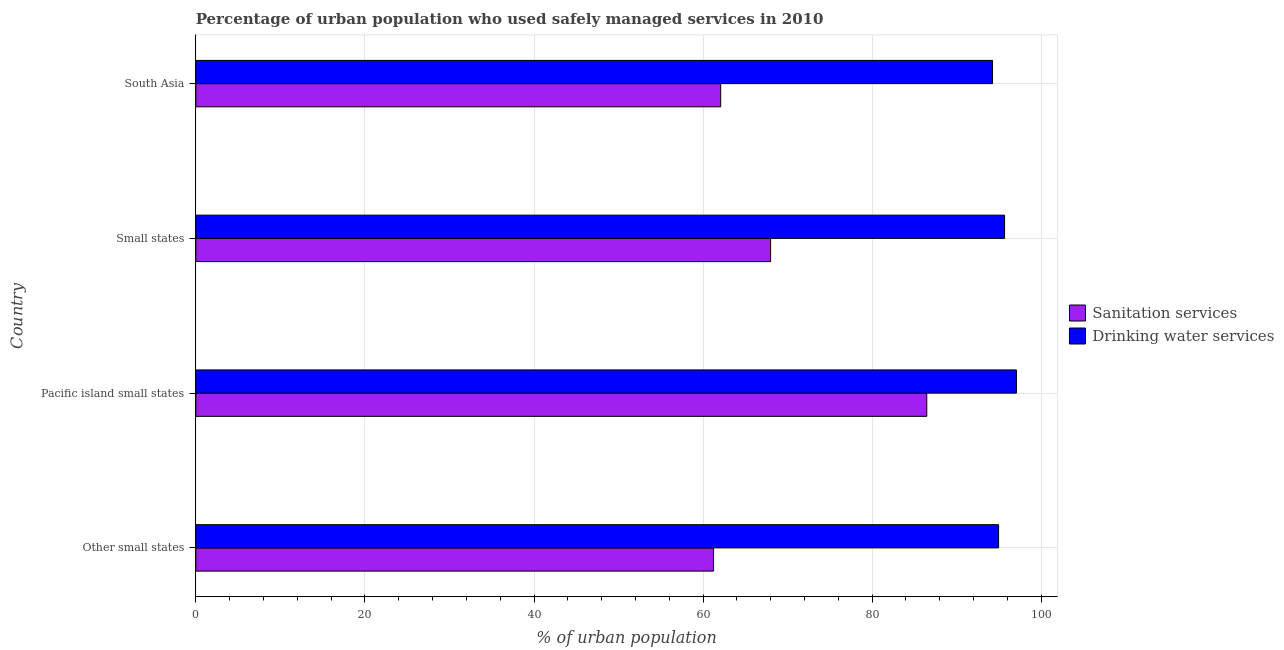Are the number of bars on each tick of the Y-axis equal?
Ensure brevity in your answer.  Yes. How many bars are there on the 2nd tick from the top?
Offer a terse response. 2. How many bars are there on the 2nd tick from the bottom?
Ensure brevity in your answer.  2. What is the label of the 3rd group of bars from the top?
Give a very brief answer. Pacific island small states. What is the percentage of urban population who used drinking water services in Small states?
Keep it short and to the point. 95.66. Across all countries, what is the maximum percentage of urban population who used drinking water services?
Your response must be concise. 97.07. Across all countries, what is the minimum percentage of urban population who used sanitation services?
Offer a very short reply. 61.24. In which country was the percentage of urban population who used drinking water services maximum?
Your answer should be very brief. Pacific island small states. In which country was the percentage of urban population who used drinking water services minimum?
Keep it short and to the point. South Asia. What is the total percentage of urban population who used sanitation services in the graph?
Provide a succinct answer. 277.77. What is the difference between the percentage of urban population who used sanitation services in Other small states and that in Pacific island small states?
Give a very brief answer. -25.22. What is the difference between the percentage of urban population who used sanitation services in Pacific island small states and the percentage of urban population who used drinking water services in Small states?
Make the answer very short. -9.2. What is the average percentage of urban population who used drinking water services per country?
Offer a very short reply. 95.48. What is the difference between the percentage of urban population who used drinking water services and percentage of urban population who used sanitation services in Other small states?
Offer a terse response. 33.72. In how many countries, is the percentage of urban population who used drinking water services greater than 60 %?
Offer a terse response. 4. Is the percentage of urban population who used sanitation services in Other small states less than that in Pacific island small states?
Make the answer very short. Yes. What is the difference between the highest and the second highest percentage of urban population who used sanitation services?
Your answer should be compact. 18.47. What is the difference between the highest and the lowest percentage of urban population who used drinking water services?
Your answer should be compact. 2.83. Is the sum of the percentage of urban population who used drinking water services in Pacific island small states and Small states greater than the maximum percentage of urban population who used sanitation services across all countries?
Your answer should be compact. Yes. What does the 2nd bar from the top in Pacific island small states represents?
Ensure brevity in your answer.  Sanitation services. What does the 2nd bar from the bottom in South Asia represents?
Make the answer very short. Drinking water services. How many bars are there?
Your answer should be compact. 8. How many countries are there in the graph?
Provide a succinct answer. 4. Does the graph contain any zero values?
Ensure brevity in your answer.  No. Does the graph contain grids?
Keep it short and to the point. Yes. How many legend labels are there?
Provide a short and direct response. 2. How are the legend labels stacked?
Your answer should be compact. Vertical. What is the title of the graph?
Keep it short and to the point. Percentage of urban population who used safely managed services in 2010. What is the label or title of the X-axis?
Give a very brief answer. % of urban population. What is the label or title of the Y-axis?
Your answer should be very brief. Country. What is the % of urban population in Sanitation services in Other small states?
Keep it short and to the point. 61.24. What is the % of urban population in Drinking water services in Other small states?
Keep it short and to the point. 94.96. What is the % of urban population of Sanitation services in Pacific island small states?
Make the answer very short. 86.46. What is the % of urban population in Drinking water services in Pacific island small states?
Provide a short and direct response. 97.07. What is the % of urban population of Sanitation services in Small states?
Ensure brevity in your answer.  67.99. What is the % of urban population of Drinking water services in Small states?
Offer a terse response. 95.66. What is the % of urban population of Sanitation services in South Asia?
Offer a terse response. 62.08. What is the % of urban population of Drinking water services in South Asia?
Ensure brevity in your answer.  94.24. Across all countries, what is the maximum % of urban population in Sanitation services?
Keep it short and to the point. 86.46. Across all countries, what is the maximum % of urban population in Drinking water services?
Ensure brevity in your answer.  97.07. Across all countries, what is the minimum % of urban population in Sanitation services?
Your response must be concise. 61.24. Across all countries, what is the minimum % of urban population in Drinking water services?
Provide a succinct answer. 94.24. What is the total % of urban population of Sanitation services in the graph?
Your response must be concise. 277.77. What is the total % of urban population in Drinking water services in the graph?
Your answer should be very brief. 381.92. What is the difference between the % of urban population of Sanitation services in Other small states and that in Pacific island small states?
Your response must be concise. -25.22. What is the difference between the % of urban population in Drinking water services in Other small states and that in Pacific island small states?
Ensure brevity in your answer.  -2.11. What is the difference between the % of urban population of Sanitation services in Other small states and that in Small states?
Provide a succinct answer. -6.75. What is the difference between the % of urban population of Drinking water services in Other small states and that in Small states?
Your answer should be compact. -0.71. What is the difference between the % of urban population of Sanitation services in Other small states and that in South Asia?
Your answer should be compact. -0.84. What is the difference between the % of urban population of Drinking water services in Other small states and that in South Asia?
Provide a succinct answer. 0.72. What is the difference between the % of urban population in Sanitation services in Pacific island small states and that in Small states?
Offer a very short reply. 18.47. What is the difference between the % of urban population in Drinking water services in Pacific island small states and that in Small states?
Give a very brief answer. 1.4. What is the difference between the % of urban population in Sanitation services in Pacific island small states and that in South Asia?
Ensure brevity in your answer.  24.38. What is the difference between the % of urban population in Drinking water services in Pacific island small states and that in South Asia?
Your answer should be compact. 2.83. What is the difference between the % of urban population in Sanitation services in Small states and that in South Asia?
Provide a short and direct response. 5.9. What is the difference between the % of urban population in Drinking water services in Small states and that in South Asia?
Offer a terse response. 1.42. What is the difference between the % of urban population of Sanitation services in Other small states and the % of urban population of Drinking water services in Pacific island small states?
Your response must be concise. -35.83. What is the difference between the % of urban population of Sanitation services in Other small states and the % of urban population of Drinking water services in Small states?
Your response must be concise. -34.42. What is the difference between the % of urban population in Sanitation services in Other small states and the % of urban population in Drinking water services in South Asia?
Give a very brief answer. -33. What is the difference between the % of urban population in Sanitation services in Pacific island small states and the % of urban population in Drinking water services in Small states?
Ensure brevity in your answer.  -9.2. What is the difference between the % of urban population of Sanitation services in Pacific island small states and the % of urban population of Drinking water services in South Asia?
Your answer should be compact. -7.78. What is the difference between the % of urban population of Sanitation services in Small states and the % of urban population of Drinking water services in South Asia?
Keep it short and to the point. -26.25. What is the average % of urban population in Sanitation services per country?
Provide a short and direct response. 69.44. What is the average % of urban population in Drinking water services per country?
Offer a very short reply. 95.48. What is the difference between the % of urban population of Sanitation services and % of urban population of Drinking water services in Other small states?
Provide a succinct answer. -33.72. What is the difference between the % of urban population in Sanitation services and % of urban population in Drinking water services in Pacific island small states?
Provide a short and direct response. -10.6. What is the difference between the % of urban population of Sanitation services and % of urban population of Drinking water services in Small states?
Keep it short and to the point. -27.67. What is the difference between the % of urban population in Sanitation services and % of urban population in Drinking water services in South Asia?
Offer a terse response. -32.15. What is the ratio of the % of urban population of Sanitation services in Other small states to that in Pacific island small states?
Your response must be concise. 0.71. What is the ratio of the % of urban population of Drinking water services in Other small states to that in Pacific island small states?
Offer a terse response. 0.98. What is the ratio of the % of urban population of Sanitation services in Other small states to that in Small states?
Make the answer very short. 0.9. What is the ratio of the % of urban population of Sanitation services in Other small states to that in South Asia?
Your answer should be compact. 0.99. What is the ratio of the % of urban population of Drinking water services in Other small states to that in South Asia?
Provide a succinct answer. 1.01. What is the ratio of the % of urban population of Sanitation services in Pacific island small states to that in Small states?
Make the answer very short. 1.27. What is the ratio of the % of urban population in Drinking water services in Pacific island small states to that in Small states?
Offer a terse response. 1.01. What is the ratio of the % of urban population in Sanitation services in Pacific island small states to that in South Asia?
Offer a terse response. 1.39. What is the ratio of the % of urban population in Sanitation services in Small states to that in South Asia?
Provide a succinct answer. 1.1. What is the ratio of the % of urban population in Drinking water services in Small states to that in South Asia?
Make the answer very short. 1.02. What is the difference between the highest and the second highest % of urban population in Sanitation services?
Give a very brief answer. 18.47. What is the difference between the highest and the second highest % of urban population in Drinking water services?
Give a very brief answer. 1.4. What is the difference between the highest and the lowest % of urban population of Sanitation services?
Your answer should be very brief. 25.22. What is the difference between the highest and the lowest % of urban population of Drinking water services?
Provide a succinct answer. 2.83. 